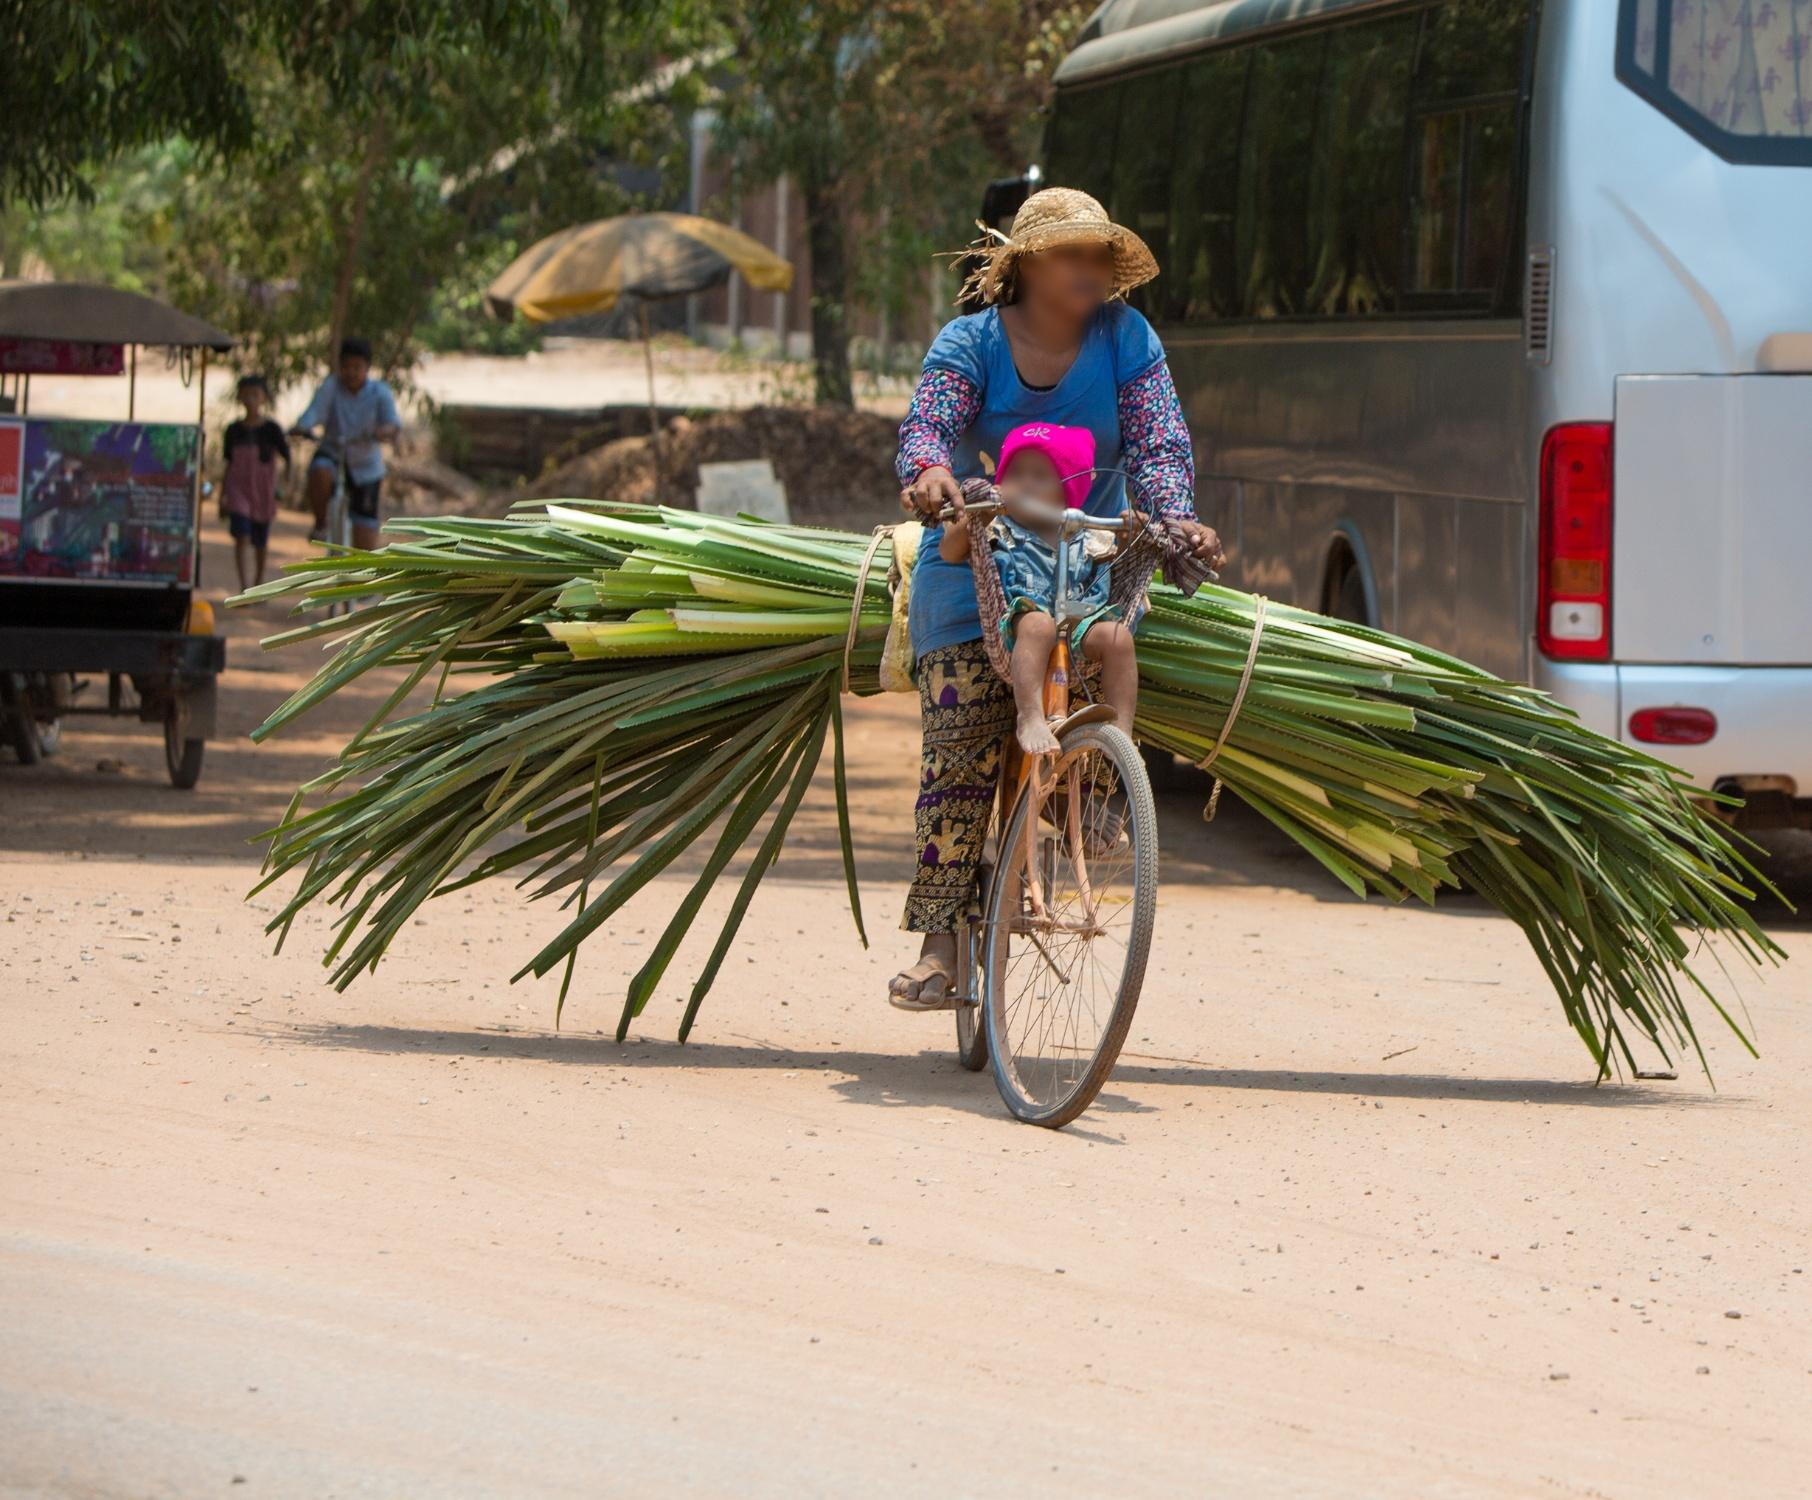What is this photo about? The image depicts a woman riding a bicycle on a dirt road in a rural area, under the bright sun. She is dressed in a vibrant pink shirt and a straw hat for protection from the sun. A large bundle of green palm leaves is secured to the back of her bicycle, almost touching the ground on both sides. The scene captures an aspect of her daily routine, suggesting she is transporting these leaves, possibly as part of her work. In the background, a white bus and a few people walking reinforce the rural setting. The sky is clear, highlighting the sunlit atmosphere of the moment. Overall, the photo gives a glimpse into the combination of daily labor and the tranquility of rural life. 